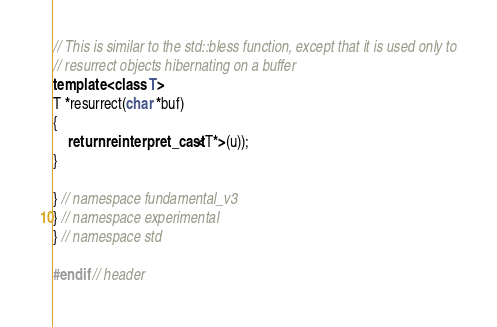<code> <loc_0><loc_0><loc_500><loc_500><_C++_>
// This is similar to the std::bless function, except that it is used only to
// resurrect objects hibernating on a buffer
template <class T>
T *resurrect(char *buf)
{
	return reinterpret_cast<T*>(u));
}

} // namespace fundamental_v3
} // namespace experimental
} // namespace std

#endif // header
</code> 